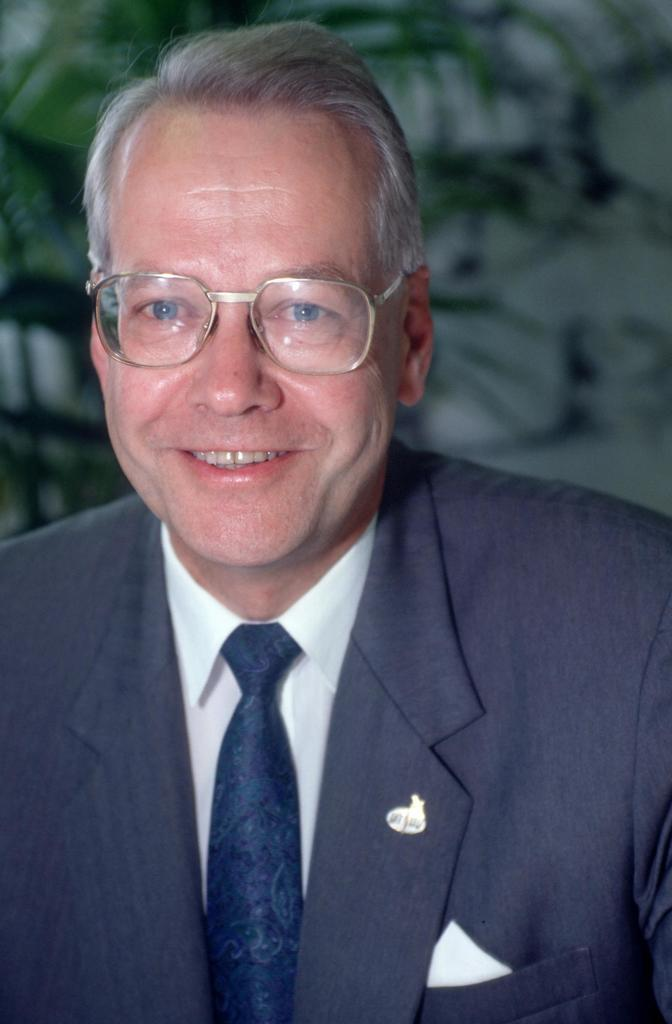Who is the main subject in the image? There is an old man in the image. What is the old man wearing? The old man is wearing a suit and glasses. What expression does the old man have? The old man is smiling. Can you describe the background of the image? The background of the image is blurry. What else can be seen in the image besides the old man? There is a plant visible in the image. What type of shop can be seen in the background of the image? There is no shop visible in the image; the background is blurry and only a plant can be seen. What time of day is it in the image, considering the old man's attire? There is no specific time of day indicated by the old man's attire, as suits can be worn at any time. 